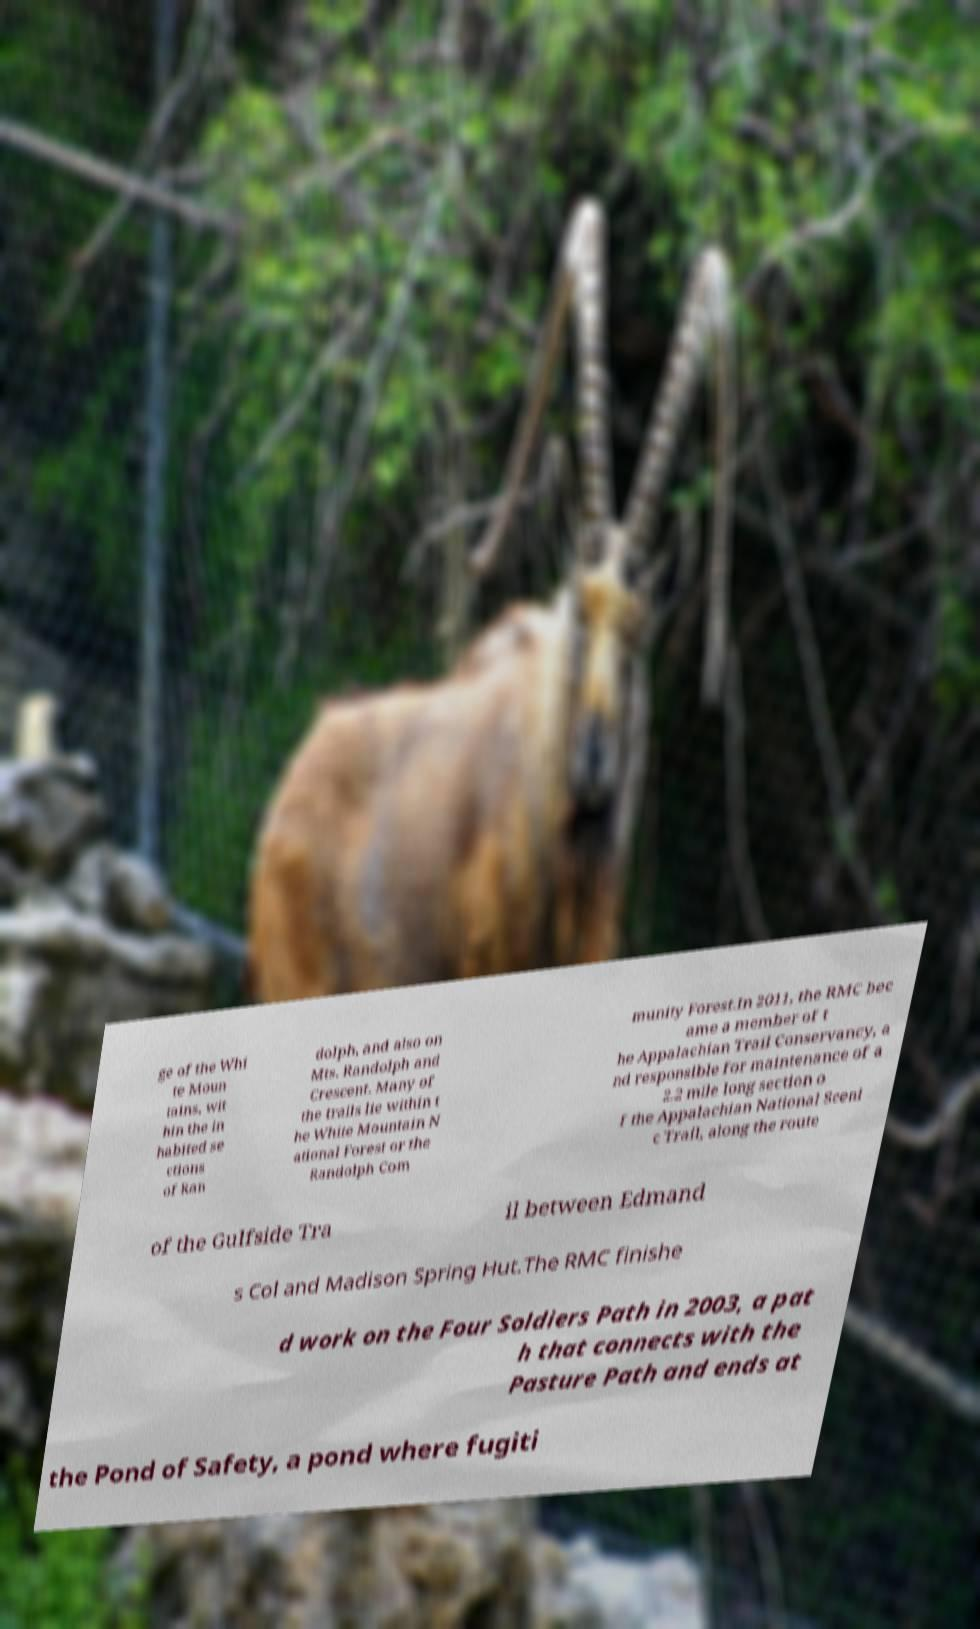What messages or text are displayed in this image? I need them in a readable, typed format. ge of the Whi te Moun tains, wit hin the in habited se ctions of Ran dolph, and also on Mts. Randolph and Crescent. Many of the trails lie within t he White Mountain N ational Forest or the Randolph Com munity Forest.In 2011, the RMC bec ame a member of t he Appalachian Trail Conservancy, a nd responsible for maintenance of a 2.2 mile long section o f the Appalachian National Sceni c Trail, along the route of the Gulfside Tra il between Edmand s Col and Madison Spring Hut.The RMC finishe d work on the Four Soldiers Path in 2003, a pat h that connects with the Pasture Path and ends at the Pond of Safety, a pond where fugiti 